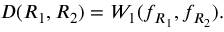Convert formula to latex. <formula><loc_0><loc_0><loc_500><loc_500>D ( R _ { 1 } , R _ { 2 } ) = W _ { 1 } ( f _ { R _ { 1 } } , f _ { R _ { 2 } } ) .</formula> 